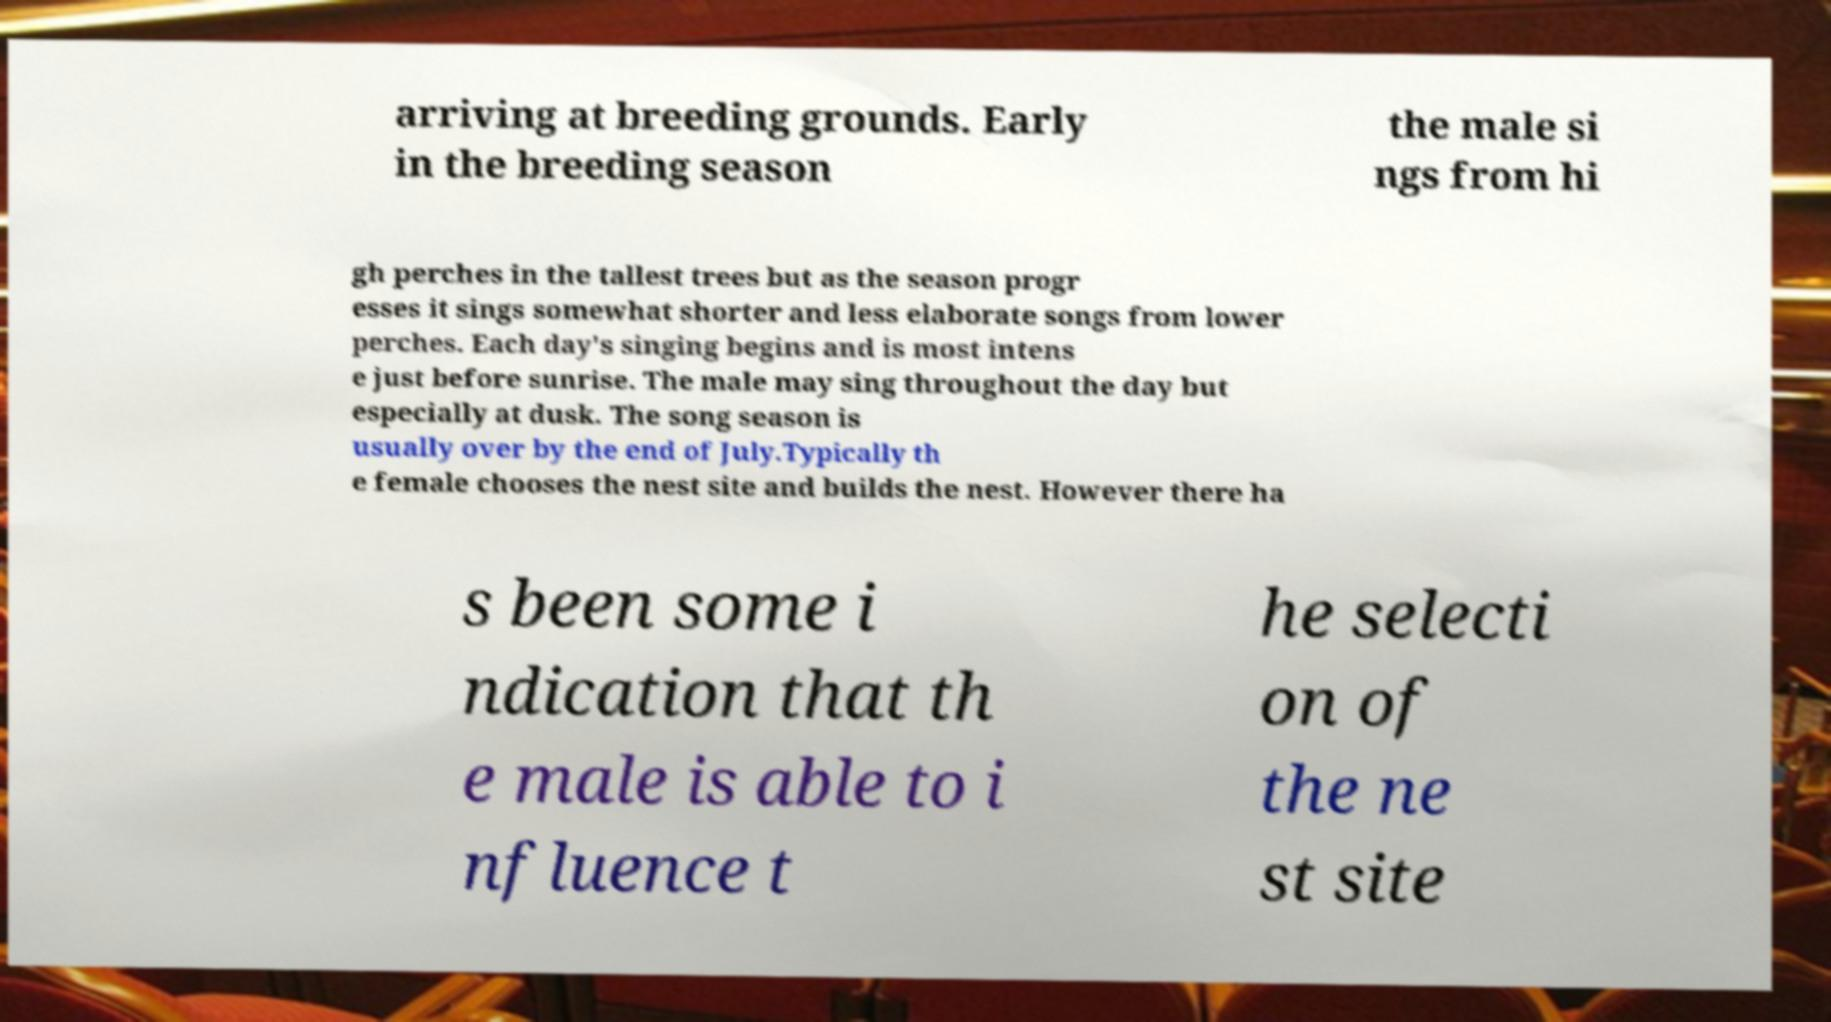I need the written content from this picture converted into text. Can you do that? arriving at breeding grounds. Early in the breeding season the male si ngs from hi gh perches in the tallest trees but as the season progr esses it sings somewhat shorter and less elaborate songs from lower perches. Each day's singing begins and is most intens e just before sunrise. The male may sing throughout the day but especially at dusk. The song season is usually over by the end of July.Typically th e female chooses the nest site and builds the nest. However there ha s been some i ndication that th e male is able to i nfluence t he selecti on of the ne st site 